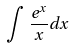<formula> <loc_0><loc_0><loc_500><loc_500>\int \frac { e ^ { x } } { x } d x</formula> 